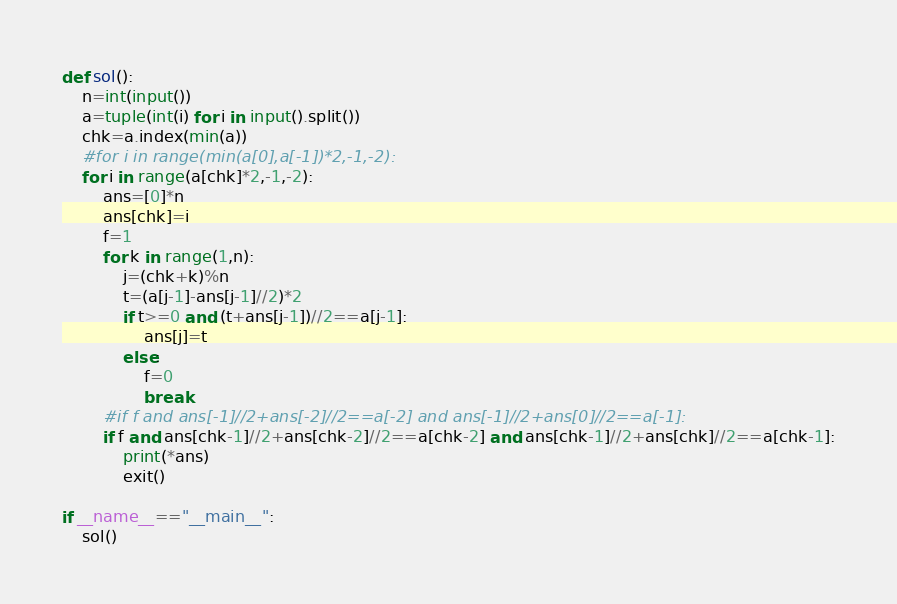Convert code to text. <code><loc_0><loc_0><loc_500><loc_500><_Python_>def sol():
    n=int(input())
    a=tuple(int(i) for i in input().split())
    chk=a.index(min(a))
    #for i in range(min(a[0],a[-1])*2,-1,-2):
    for i in range(a[chk]*2,-1,-2):
        ans=[0]*n
        ans[chk]=i
        f=1
        for k in range(1,n):
            j=(chk+k)%n
            t=(a[j-1]-ans[j-1]//2)*2
            if t>=0 and (t+ans[j-1])//2==a[j-1]:
                ans[j]=t
            else:
                f=0
                break
        #if f and ans[-1]//2+ans[-2]//2==a[-2] and ans[-1]//2+ans[0]//2==a[-1]:
        if f and ans[chk-1]//2+ans[chk-2]//2==a[chk-2] and ans[chk-1]//2+ans[chk]//2==a[chk-1]:
            print(*ans)
            exit()

if __name__=="__main__":
    sol()</code> 